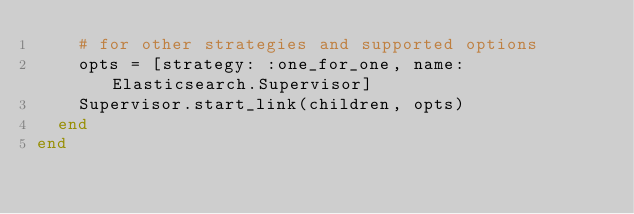Convert code to text. <code><loc_0><loc_0><loc_500><loc_500><_Elixir_>    # for other strategies and supported options
    opts = [strategy: :one_for_one, name: Elasticsearch.Supervisor]
    Supervisor.start_link(children, opts)
  end
end
</code> 